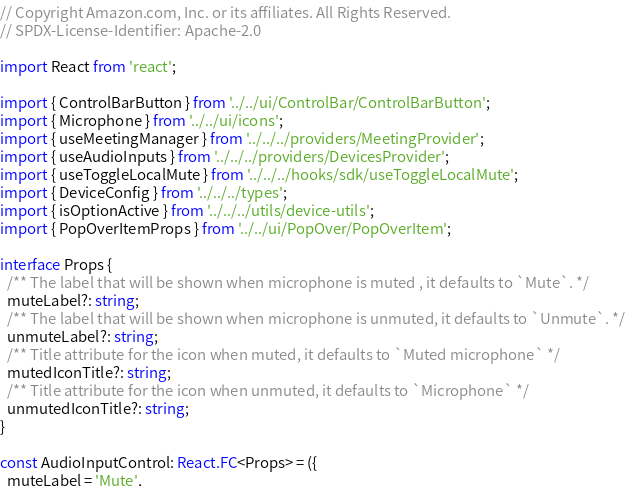<code> <loc_0><loc_0><loc_500><loc_500><_TypeScript_>// Copyright Amazon.com, Inc. or its affiliates. All Rights Reserved.
// SPDX-License-Identifier: Apache-2.0

import React from 'react';

import { ControlBarButton } from '../../ui/ControlBar/ControlBarButton';
import { Microphone } from '../../ui/icons';
import { useMeetingManager } from '../../../providers/MeetingProvider';
import { useAudioInputs } from '../../../providers/DevicesProvider';
import { useToggleLocalMute } from '../../../hooks/sdk/useToggleLocalMute';
import { DeviceConfig } from '../../../types';
import { isOptionActive } from '../../../utils/device-utils';
import { PopOverItemProps } from '../../ui/PopOver/PopOverItem';

interface Props {
  /** The label that will be shown when microphone is muted , it defaults to `Mute`. */
  muteLabel?: string;
  /** The label that will be shown when microphone is unmuted, it defaults to `Unmute`. */
  unmuteLabel?: string;
  /** Title attribute for the icon when muted, it defaults to `Muted microphone` */
  mutedIconTitle?: string;
  /** Title attribute for the icon when unmuted, it defaults to `Microphone` */
  unmutedIconTitle?: string;
}

const AudioInputControl: React.FC<Props> = ({
  muteLabel = 'Mute',</code> 